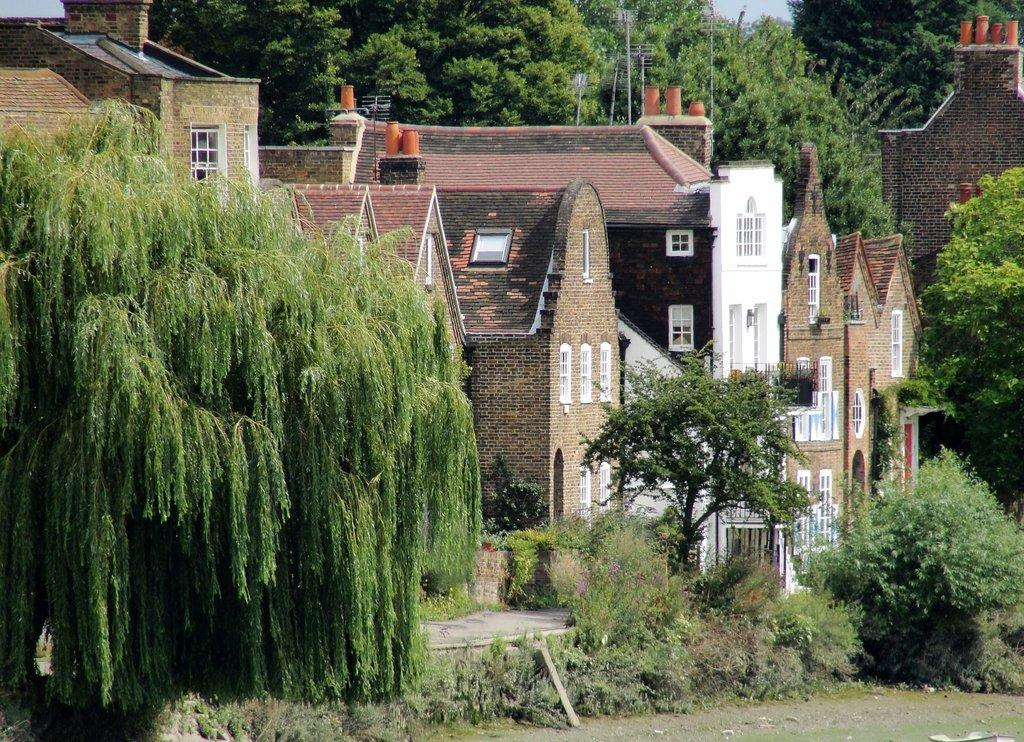What type of vegetation can be seen in the image? There are trees in the image. What type of structures are visible in the image? There are houses in the image. What caption is written on the trees in the image? There is no caption written on the trees in the image; they are simply trees. 